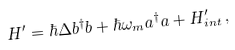<formula> <loc_0><loc_0><loc_500><loc_500>H ^ { \prime } = \hbar { \Delta } b ^ { \dag } b + \hbar { \omega } _ { m } a ^ { \dag } a + H ^ { \prime } _ { i n t } \, ,</formula> 